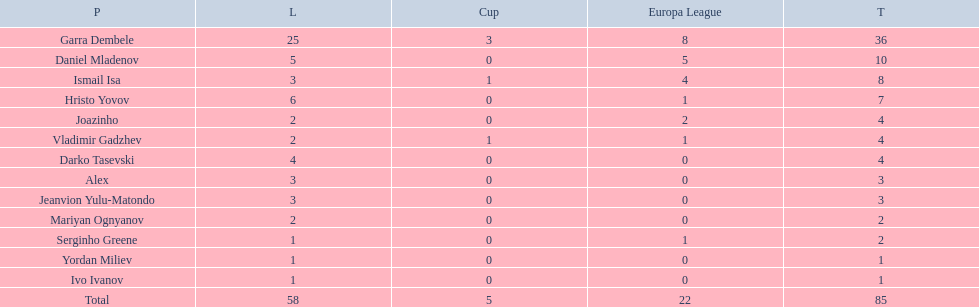How many players had a total of 4? 3. 